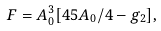Convert formula to latex. <formula><loc_0><loc_0><loc_500><loc_500>F = A _ { 0 } ^ { 3 } [ 4 5 A _ { 0 } / 4 - g _ { 2 } ] ,</formula> 